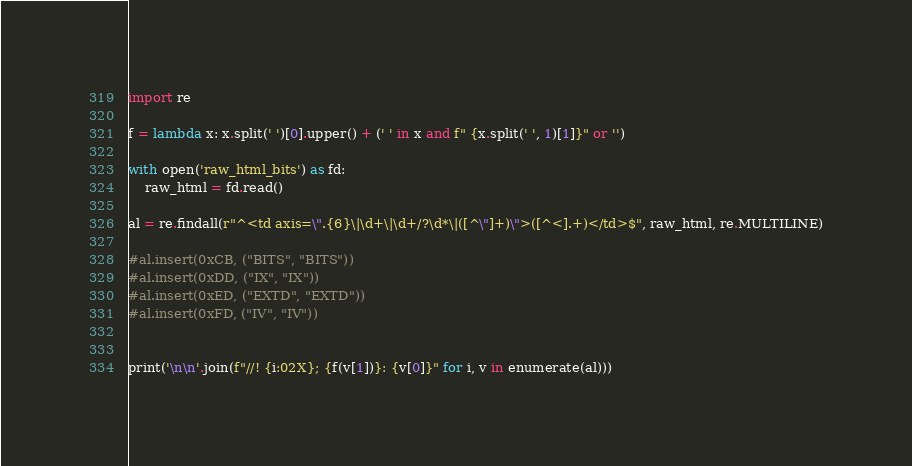Convert code to text. <code><loc_0><loc_0><loc_500><loc_500><_Python_>import re

f = lambda x: x.split(' ')[0].upper() + (' ' in x and f" {x.split(' ', 1)[1]}" or '')

with open('raw_html_bits') as fd:
    raw_html = fd.read()

al = re.findall(r"^<td axis=\".{6}\|\d+\|\d+/?\d*\|([^\"]+)\">([^<].+)</td>$", raw_html, re.MULTILINE)

#al.insert(0xCB, ("BITS", "BITS"))
#al.insert(0xDD, ("IX", "IX"))
#al.insert(0xED, ("EXTD", "EXTD"))
#al.insert(0xFD, ("IV", "IV"))


print('\n\n'.join(f"//! {i:02X}; {f(v[1])}: {v[0]}" for i, v in enumerate(al)))
</code> 